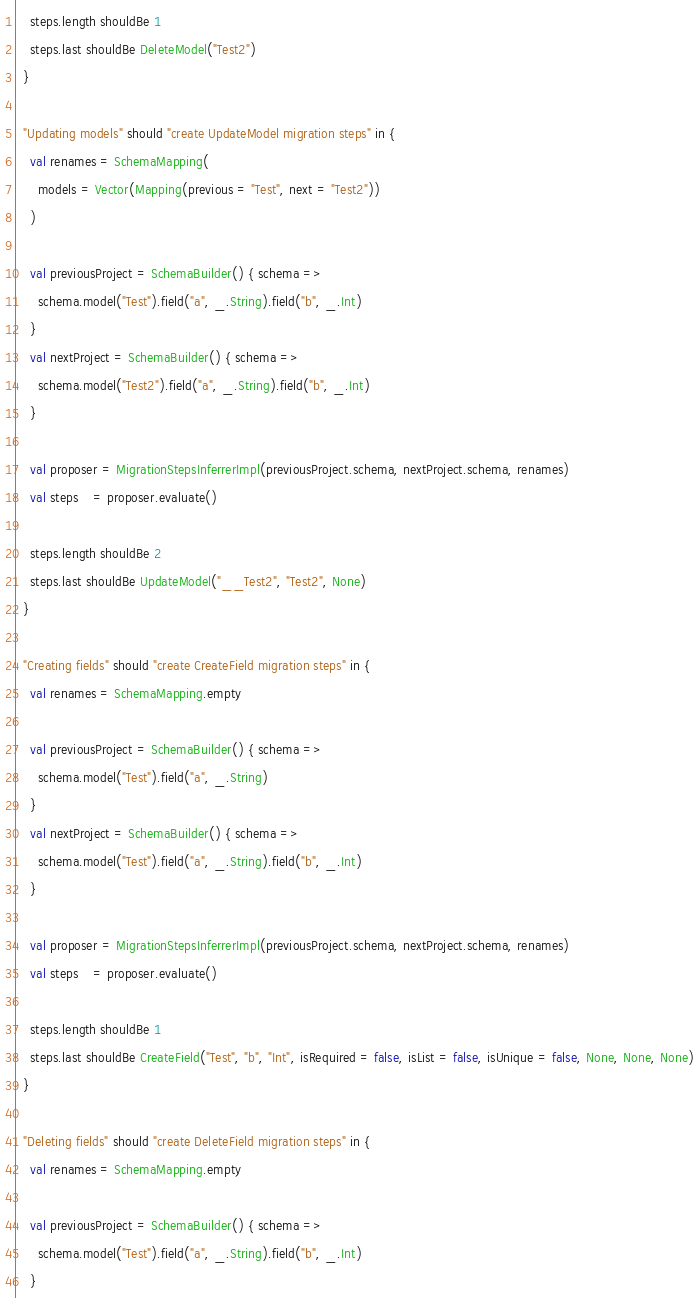Convert code to text. <code><loc_0><loc_0><loc_500><loc_500><_Scala_>    steps.length shouldBe 1
    steps.last shouldBe DeleteModel("Test2")
  }

  "Updating models" should "create UpdateModel migration steps" in {
    val renames = SchemaMapping(
      models = Vector(Mapping(previous = "Test", next = "Test2"))
    )

    val previousProject = SchemaBuilder() { schema =>
      schema.model("Test").field("a", _.String).field("b", _.Int)
    }
    val nextProject = SchemaBuilder() { schema =>
      schema.model("Test2").field("a", _.String).field("b", _.Int)
    }

    val proposer = MigrationStepsInferrerImpl(previousProject.schema, nextProject.schema, renames)
    val steps    = proposer.evaluate()

    steps.length shouldBe 2
    steps.last shouldBe UpdateModel("__Test2", "Test2", None)
  }

  "Creating fields" should "create CreateField migration steps" in {
    val renames = SchemaMapping.empty

    val previousProject = SchemaBuilder() { schema =>
      schema.model("Test").field("a", _.String)
    }
    val nextProject = SchemaBuilder() { schema =>
      schema.model("Test").field("a", _.String).field("b", _.Int)
    }

    val proposer = MigrationStepsInferrerImpl(previousProject.schema, nextProject.schema, renames)
    val steps    = proposer.evaluate()

    steps.length shouldBe 1
    steps.last shouldBe CreateField("Test", "b", "Int", isRequired = false, isList = false, isUnique = false, None, None, None)
  }

  "Deleting fields" should "create DeleteField migration steps" in {
    val renames = SchemaMapping.empty

    val previousProject = SchemaBuilder() { schema =>
      schema.model("Test").field("a", _.String).field("b", _.Int)
    }</code> 